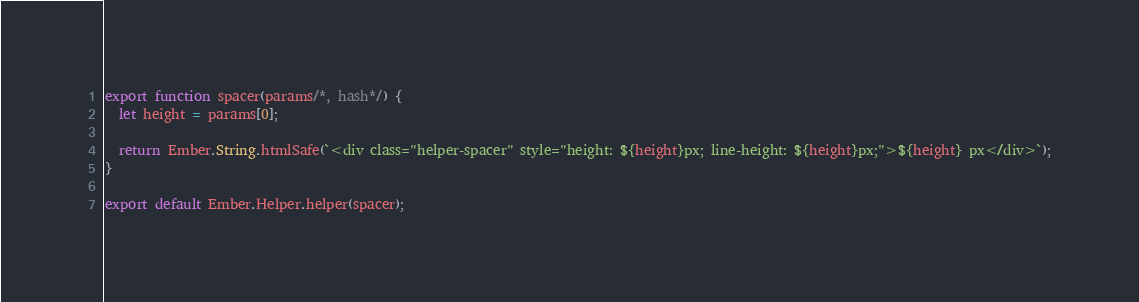Convert code to text. <code><loc_0><loc_0><loc_500><loc_500><_JavaScript_>export function spacer(params/*, hash*/) {
  let height = params[0];

  return Ember.String.htmlSafe(`<div class="helper-spacer" style="height: ${height}px; line-height: ${height}px;">${height} px</div>`);
}

export default Ember.Helper.helper(spacer);
</code> 